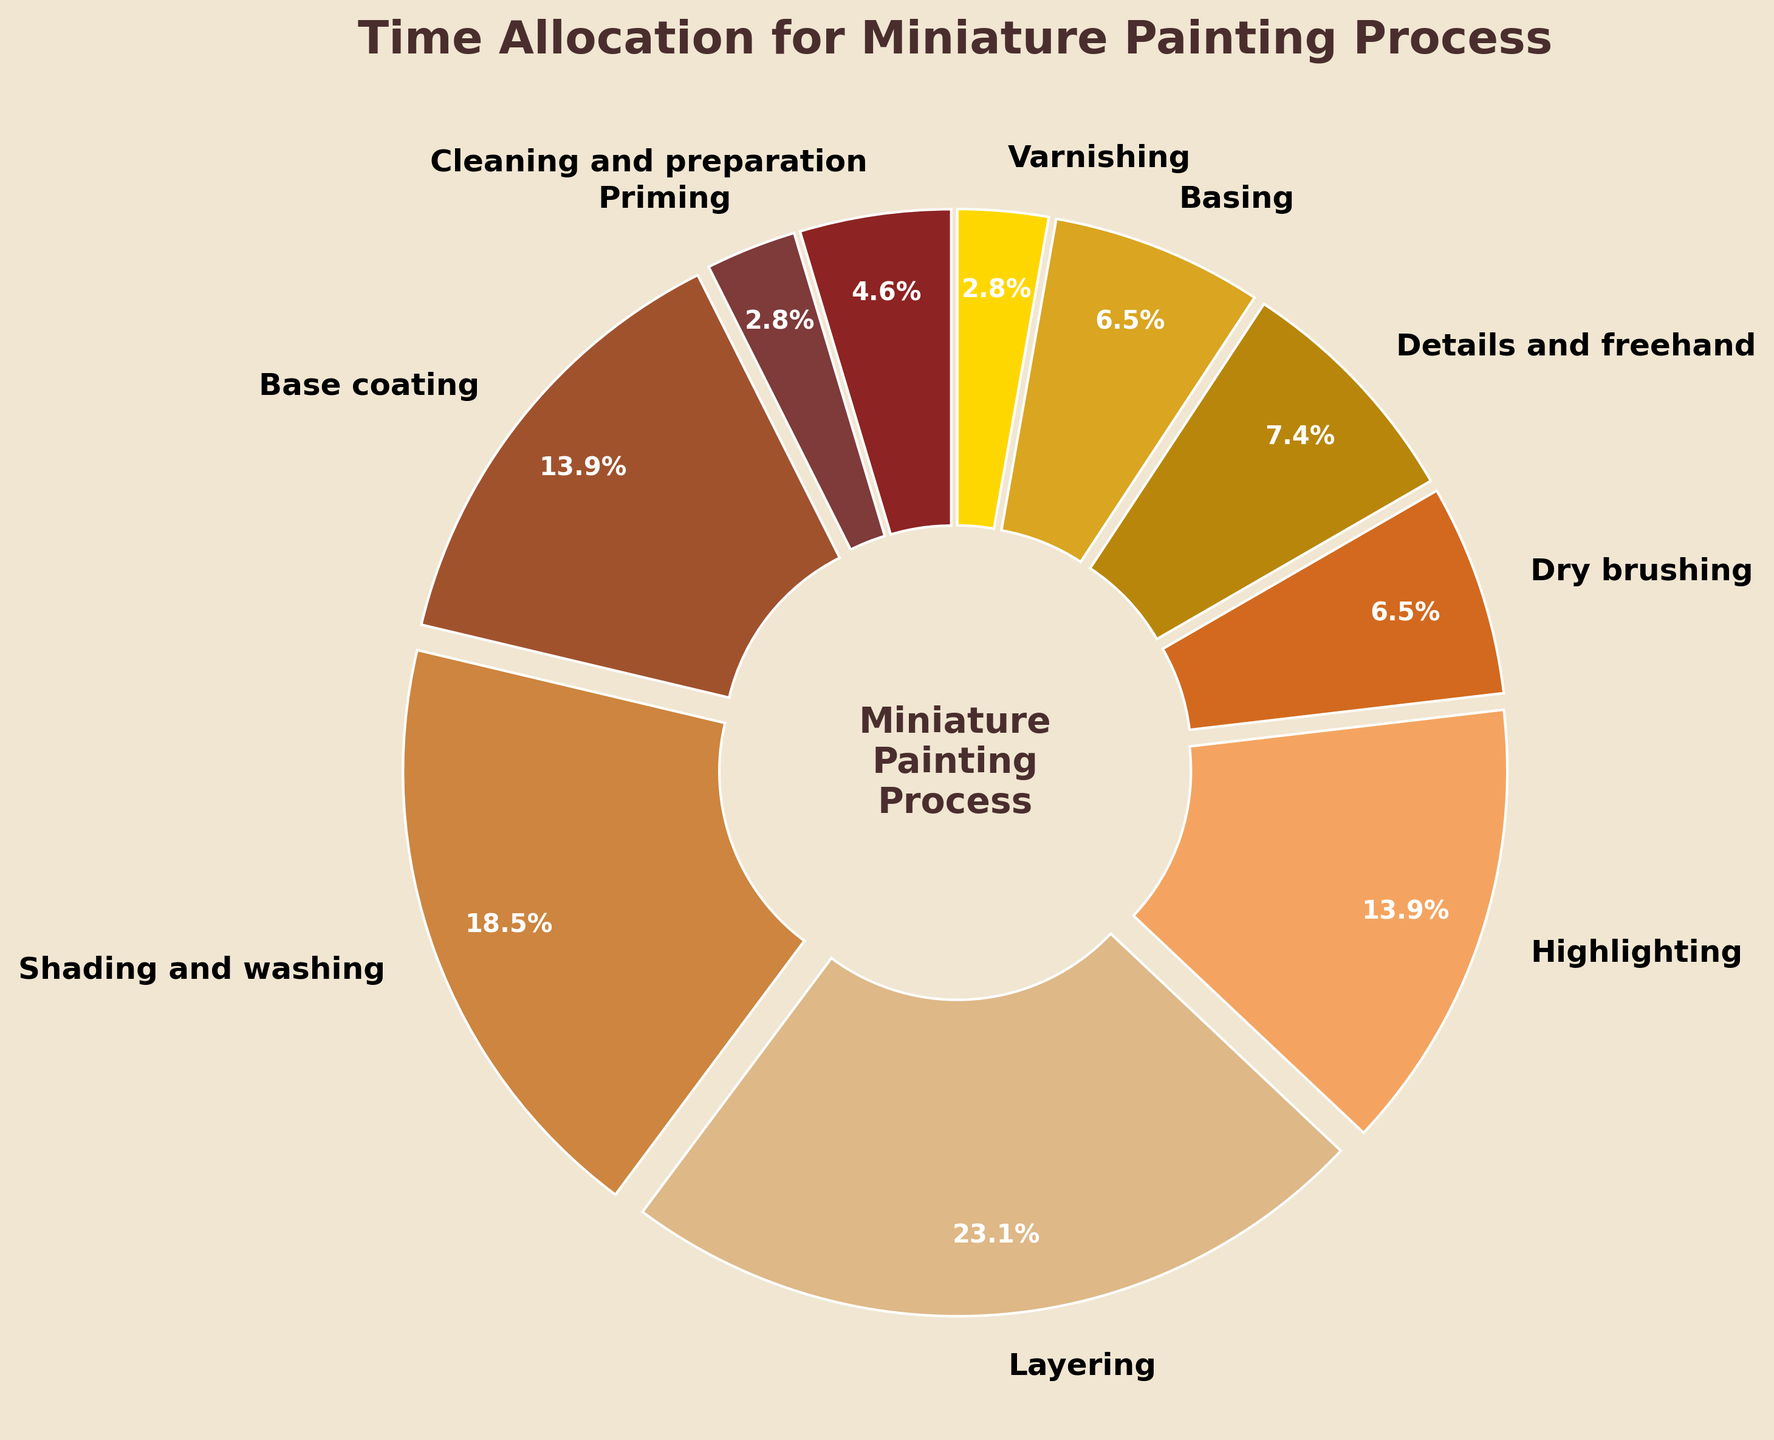Which stage takes up the most time in the miniature painting process? The figure shows a pie chart where the largest colored segment corresponds to the stage with the highest time percentage.
Answer: Layering Which two stages combined take up the same time percentage as the shading and washing stage? To find this, we need to look at two stages whose time percentages add up to the time percentage of shading and washing (20%). Base coating (15%) plus varnishing (3%) equals 18%, which means we need to find stages that add up to 5%. Cleaning and preparation (5%) and varnishing (3%) add up to 5%, so the answer should be base coating and varnishing.
Answer: Base coating and varnishing Which process stage is represented by the red segment in the figure? By examining the color used in the pie chart, the red segment represents the stage labeled as cleaning and preparation.
Answer: Cleaning and preparation How much more time is spent on base coating compared to priming? According to the figure, the time percentage for base coating is 15%, and for priming, it’s 3%. The difference is calculated as 15% minus 3%, resulting in 12%.
Answer: 12% Are there any stages that take the same percentage of time? By reviewing the time percentages in the figure, we notice that priming and varnishing both take up 3% of the time each.
Answer: Priming and varnishing Which takes longer, highlighting or details and freehand? The pie chart segments indicate that highlighting takes 15% of the time, whereas details and freehand take up 8%. Therefore, highlighting takes longer.
Answer: Highlighting What is the combined time percentage for detailing and freehand, and basing stages? The figure shows that detailing and freehand take 8% and basing takes 7%. Summing them up results in 8% + 7% = 15%.
Answer: 15% What are the three stages with the smallest time allocations, and what is their combined percentage? By identifying the smallest percentages in the figure, we see that priming (3%), varnishing (3%), and cleaning and preparation (5%) are the smallest. Their combined percentage is 3% + 3% + 5% = 11%.
Answer: 11% If you were to reallocate 10% of the time from layering to the smallest time allocation stages equally, how much time would now be spent on cleaning and preparation, priming, and varnishing? Layering initially takes 25%. By deducting 10%, it becomes 15%. The smallest time stages are cleaning and preparation, priming, and varnishing which currently have 5%, 3%, and 3% respectively. Splitting the 10% equally adds approximately 3.33% to each stage. Thus, cleaning and preparation becomes 5% + 3.33% = 8.33%, priming becomes 3% + 3.33% = 6.33%, and varnishing becomes 3% + 3.33% = 6.33%.
Answer: 8.33%, 6.33%, and 6.33% Which stage has a longer time allocation: dry brushing or basing? According to the figure, dry brushing has a time percentage of 7%, and basing has 7% as well. Therefore, both stages have the same time allocation.
Answer: Same time allocation 